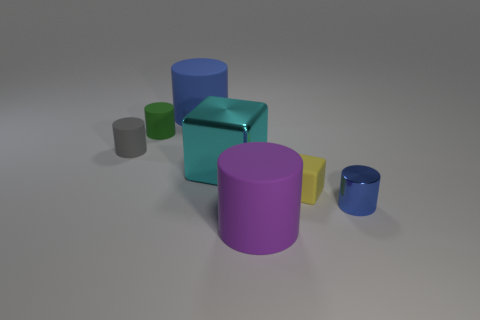Subtract all green matte cylinders. How many cylinders are left? 4 Subtract all purple cylinders. How many cylinders are left? 4 Subtract 1 cylinders. How many cylinders are left? 4 Subtract all green cylinders. Subtract all cyan spheres. How many cylinders are left? 4 Add 2 small blue balls. How many objects exist? 9 Subtract all cylinders. How many objects are left? 2 Subtract 0 purple balls. How many objects are left? 7 Subtract all purple cylinders. Subtract all purple cylinders. How many objects are left? 5 Add 7 blue rubber things. How many blue rubber things are left? 8 Add 3 big yellow balls. How many big yellow balls exist? 3 